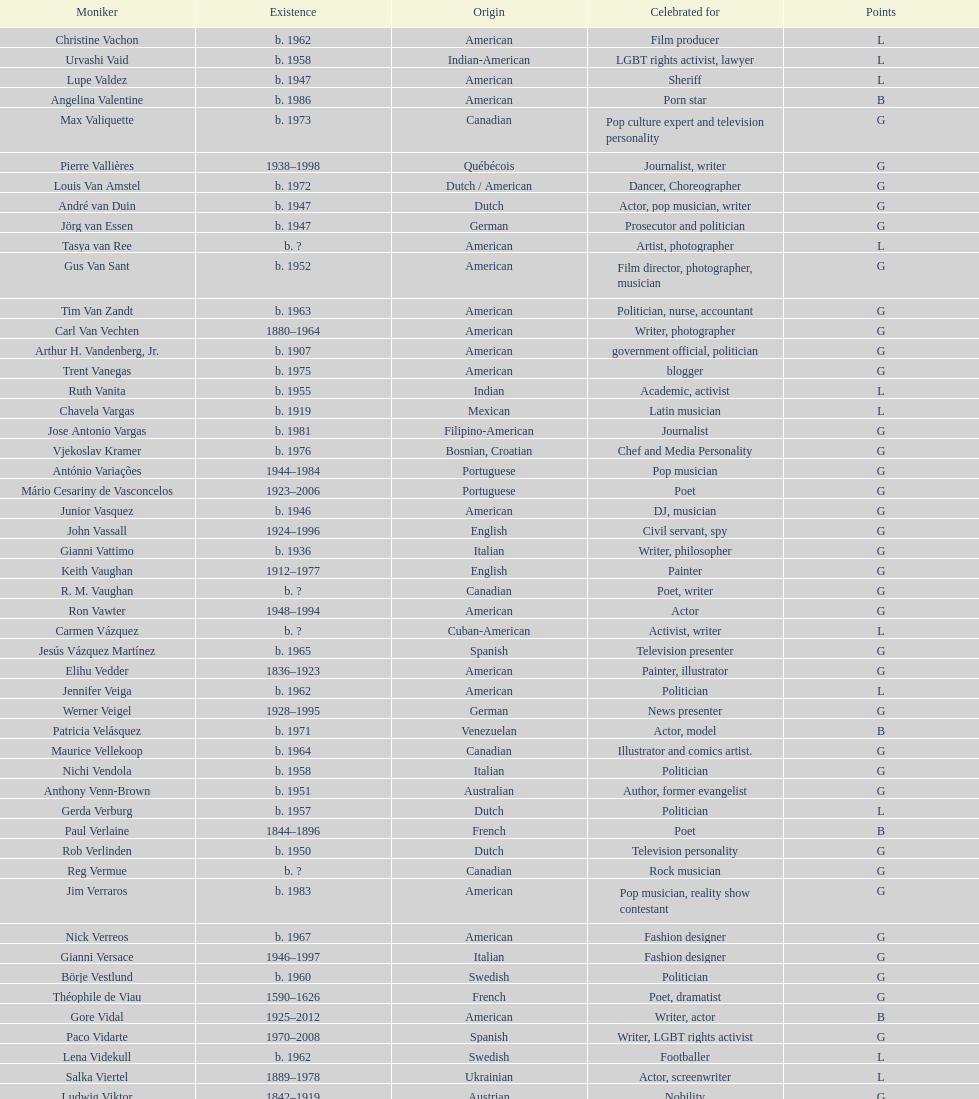What is the difference in year of borth between vachon and vaid? 4 years. 